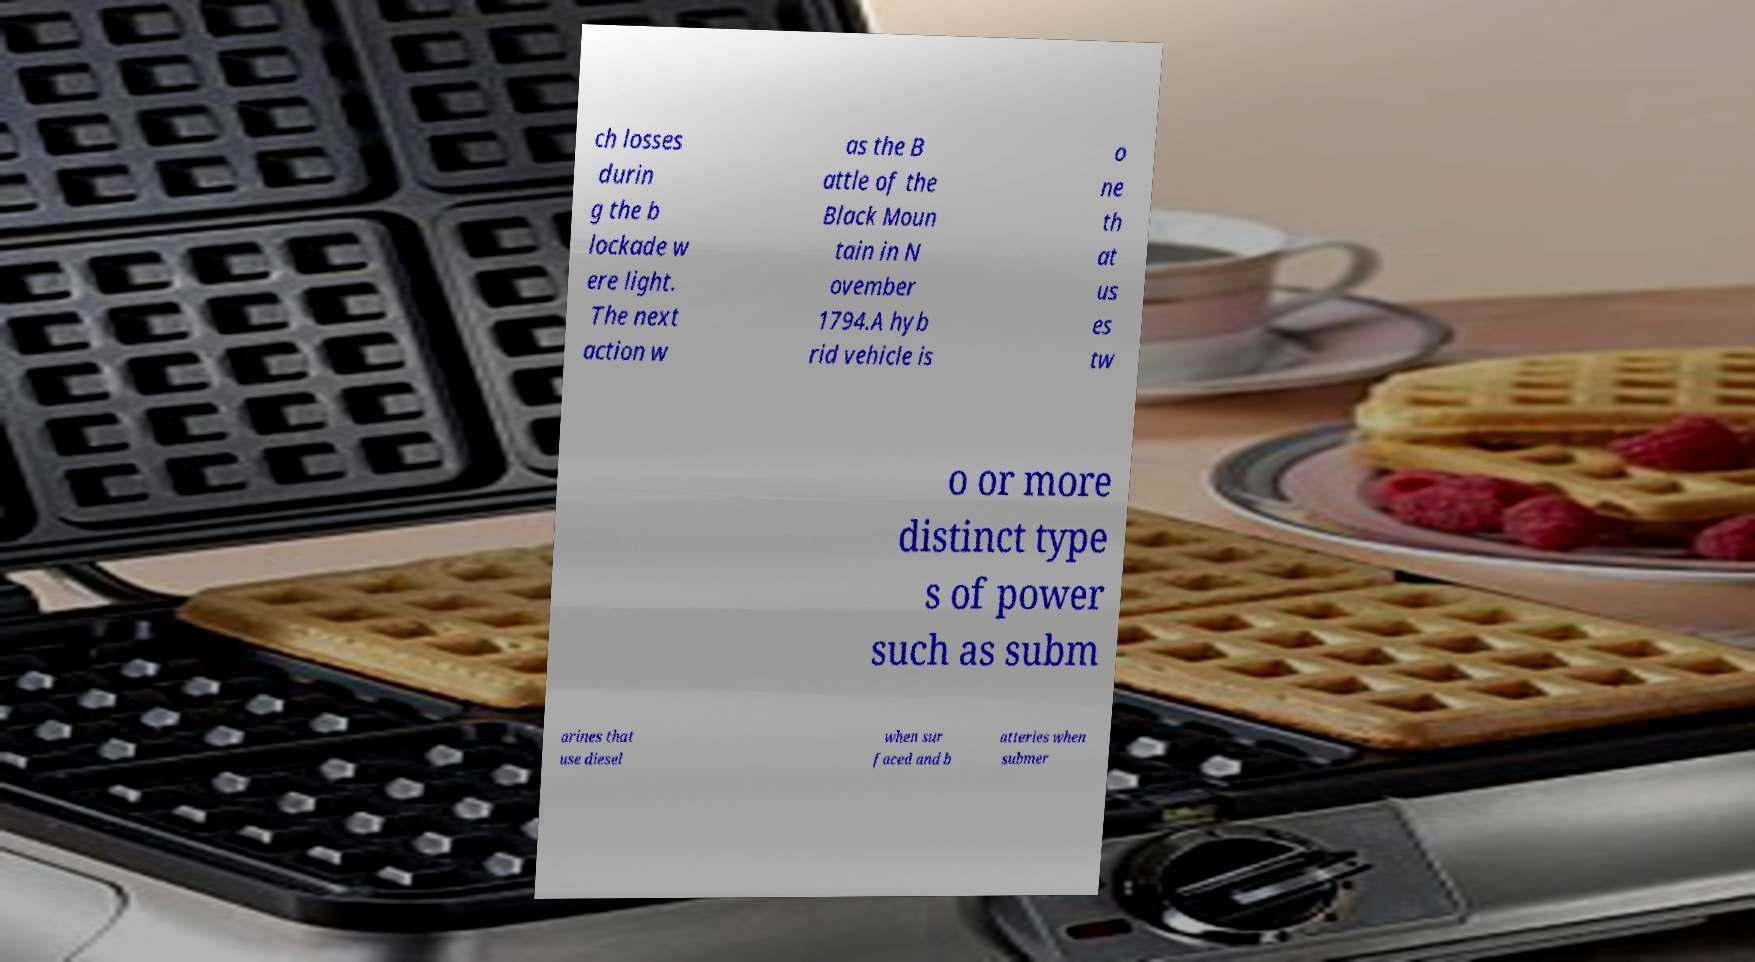There's text embedded in this image that I need extracted. Can you transcribe it verbatim? ch losses durin g the b lockade w ere light. The next action w as the B attle of the Black Moun tain in N ovember 1794.A hyb rid vehicle is o ne th at us es tw o or more distinct type s of power such as subm arines that use diesel when sur faced and b atteries when submer 